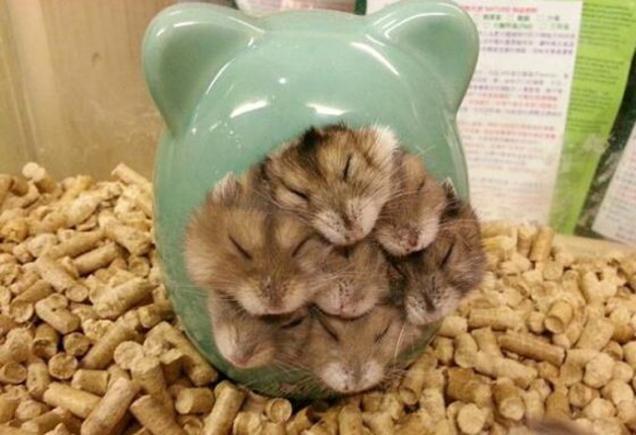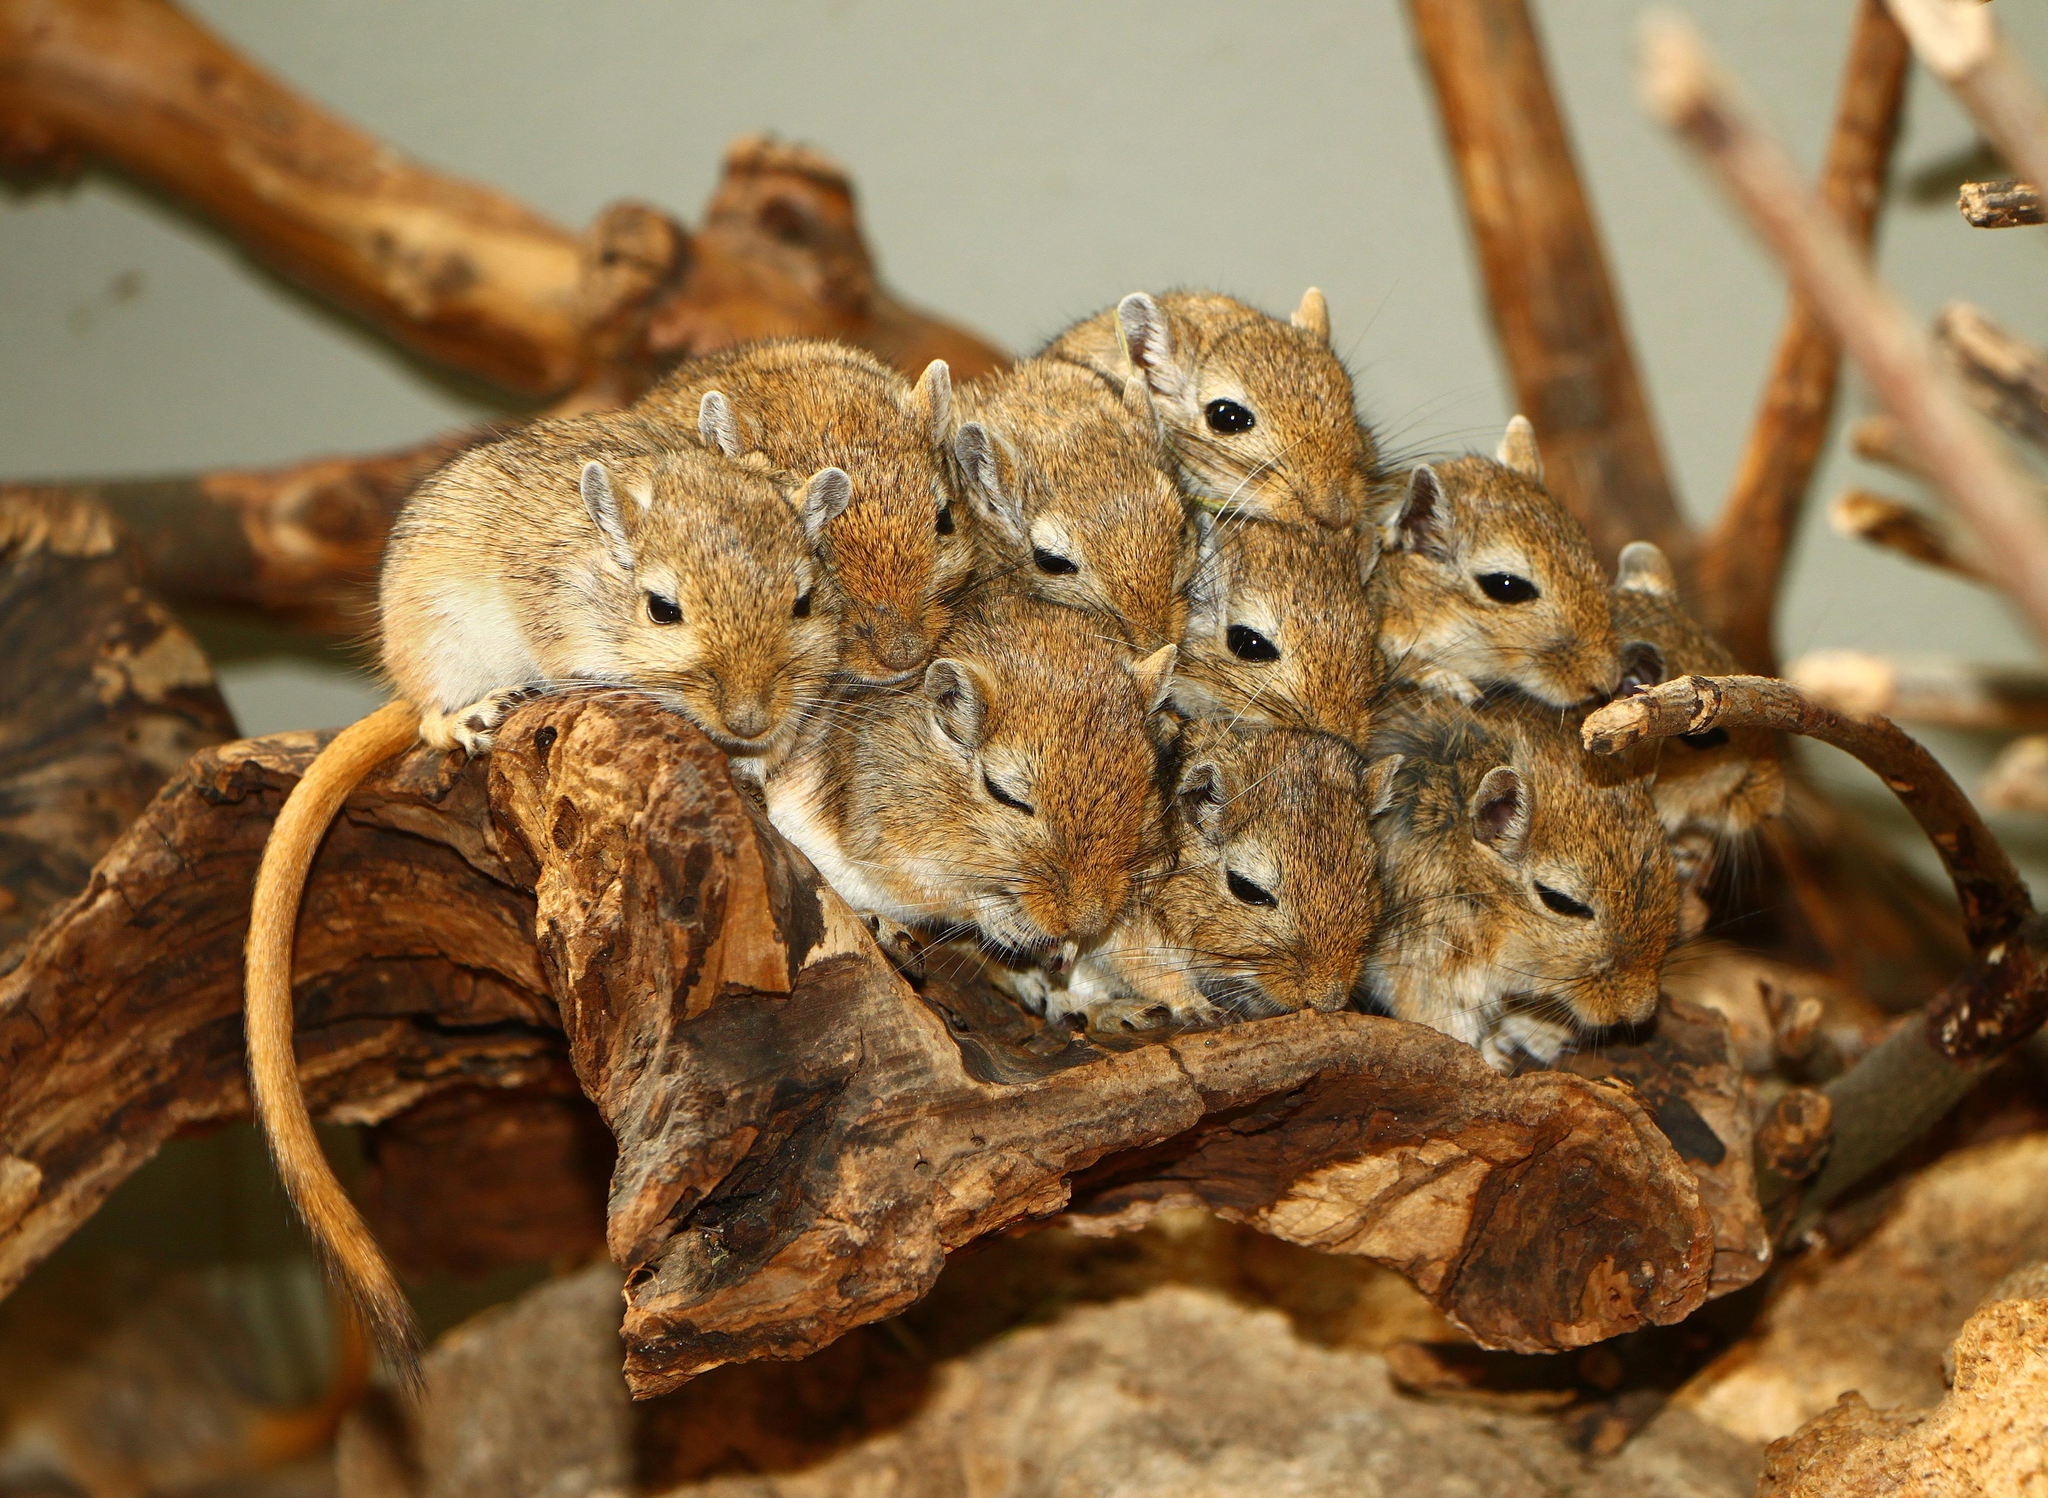The first image is the image on the left, the second image is the image on the right. Given the left and right images, does the statement "There are no more than three rodents" hold true? Answer yes or no. No. The first image is the image on the left, the second image is the image on the right. Examine the images to the left and right. Is the description "One image shows a cluster of pets inside something with ears." accurate? Answer yes or no. Yes. 